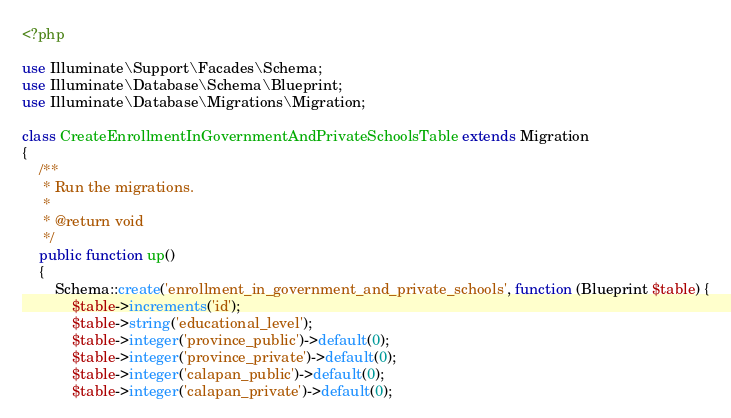<code> <loc_0><loc_0><loc_500><loc_500><_PHP_><?php

use Illuminate\Support\Facades\Schema;
use Illuminate\Database\Schema\Blueprint;
use Illuminate\Database\Migrations\Migration;

class CreateEnrollmentInGovernmentAndPrivateSchoolsTable extends Migration
{
    /**
     * Run the migrations.
     *
     * @return void
     */
    public function up()
    {
        Schema::create('enrollment_in_government_and_private_schools', function (Blueprint $table) {
            $table->increments('id');
            $table->string('educational_level');
            $table->integer('province_public')->default(0);
            $table->integer('province_private')->default(0);
            $table->integer('calapan_public')->default(0);
            $table->integer('calapan_private')->default(0);</code> 